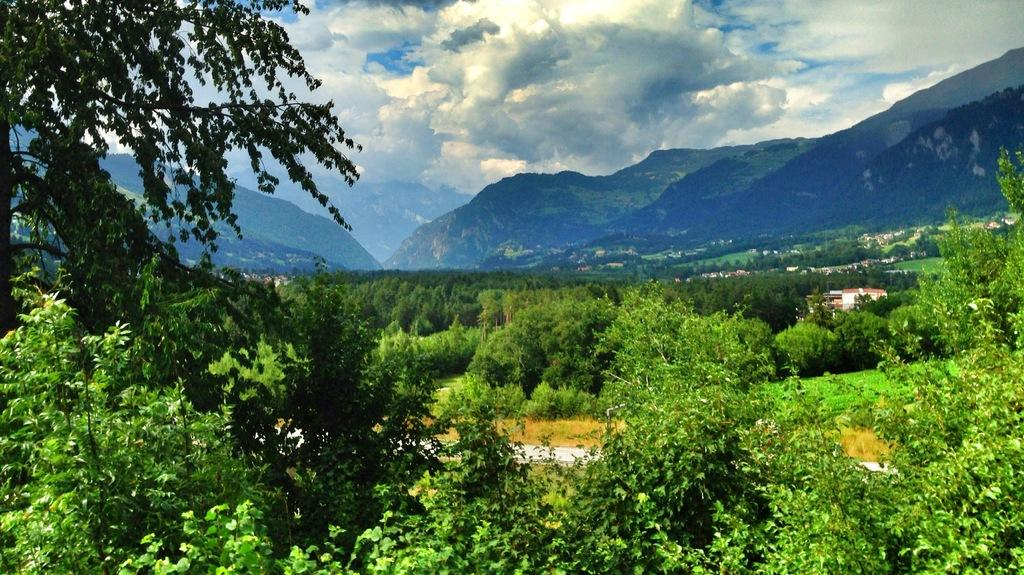What type of vegetation can be seen in the image? There are trees in the image. What can be seen in the distance behind the trees? There are hills visible in the background of the image. What is the condition of the sky in the image? The sky is cloudy in the image. What type of vegetable is being offered in the image? There is no vegetable being offered in the image; it features trees and hills in the background. What is inside the box that is visible in the image? There is no box present in the image. 